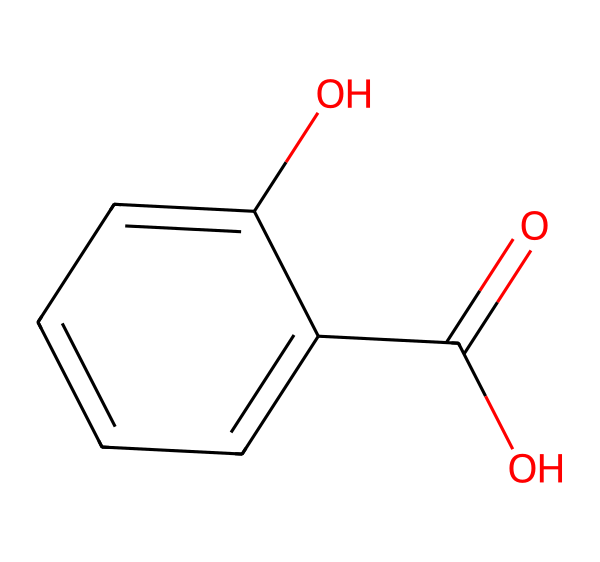What is the chemical name of this compound? The SMILES representation provided is O=C(O)c1ccccc1O, which corresponds to the chemical structure of salicylic acid.
Answer: salicylic acid How many carbon atoms are in the molecule? Analyzing the structure, the compound has a total of seven carbon (C) atoms, which are indicated in the aromatic ring and the carboxylic acid group.
Answer: seven What type of functional group is present in this structure? By examining the SMILES, we see the presence of a carboxylic acid group (–COOH) and a hydroxyl group (–OH) attached to the aromatic ring, indicating it belongs to the phenol family.
Answer: phenol What type of bond connects the carbon atoms in the aromatic ring? The carbon atoms in the aromatic ring are connected by alternating double bonds, which create resonance structures that are characteristic of aromatic compounds.
Answer: double bond How many hydroxyl groups are present in salicylic acid? From the structure, there is one hydroxyl group (-OH) present in the molecule, which contributes to its classification as a phenol.
Answer: one What property of salicylic acid is linked to its hydroxyl group? The presence of the hydroxyl group in salicylic acid is responsible for its ability to exhibit antiseptic properties, making it effective in skincare products.
Answer: antiseptic 